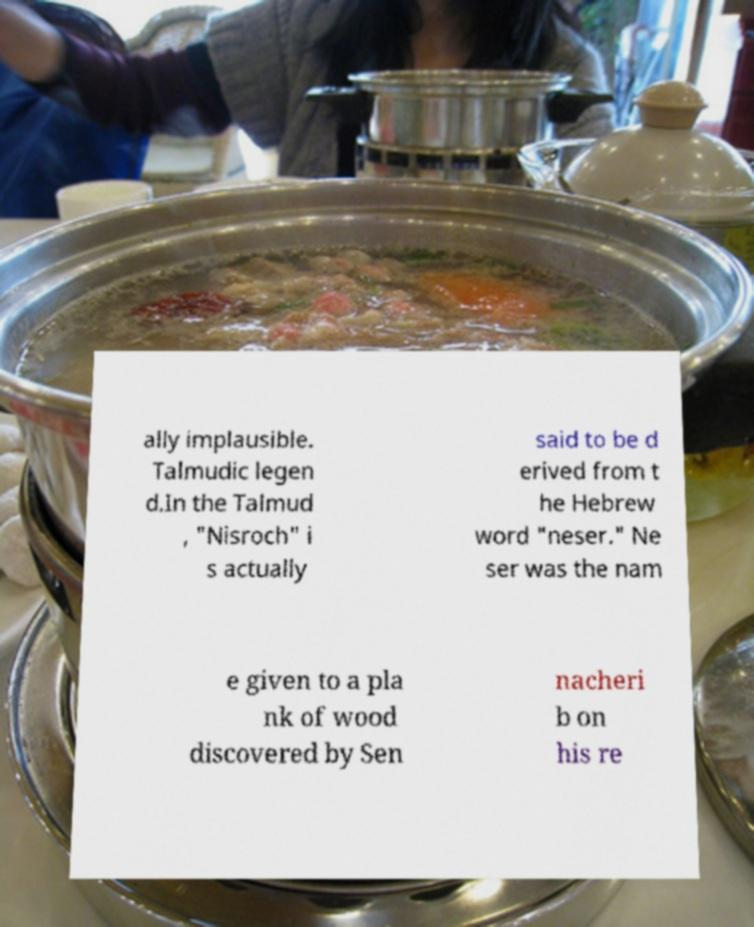Can you read and provide the text displayed in the image?This photo seems to have some interesting text. Can you extract and type it out for me? ally implausible. Talmudic legen d.In the Talmud , "Nisroch" i s actually said to be d erived from t he Hebrew word "neser." Ne ser was the nam e given to a pla nk of wood discovered by Sen nacheri b on his re 